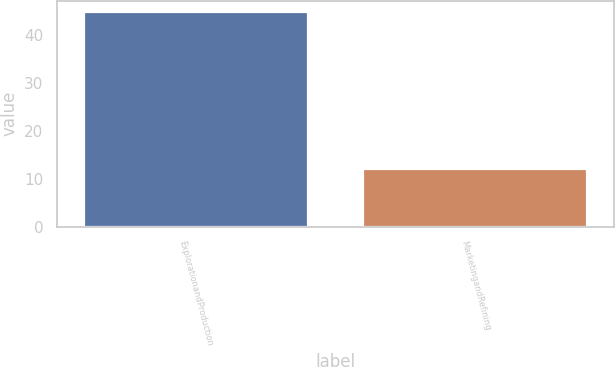Convert chart to OTSL. <chart><loc_0><loc_0><loc_500><loc_500><bar_chart><fcel>ExplorationandProduction<fcel>MarketingandRefining<nl><fcel>45<fcel>12<nl></chart> 